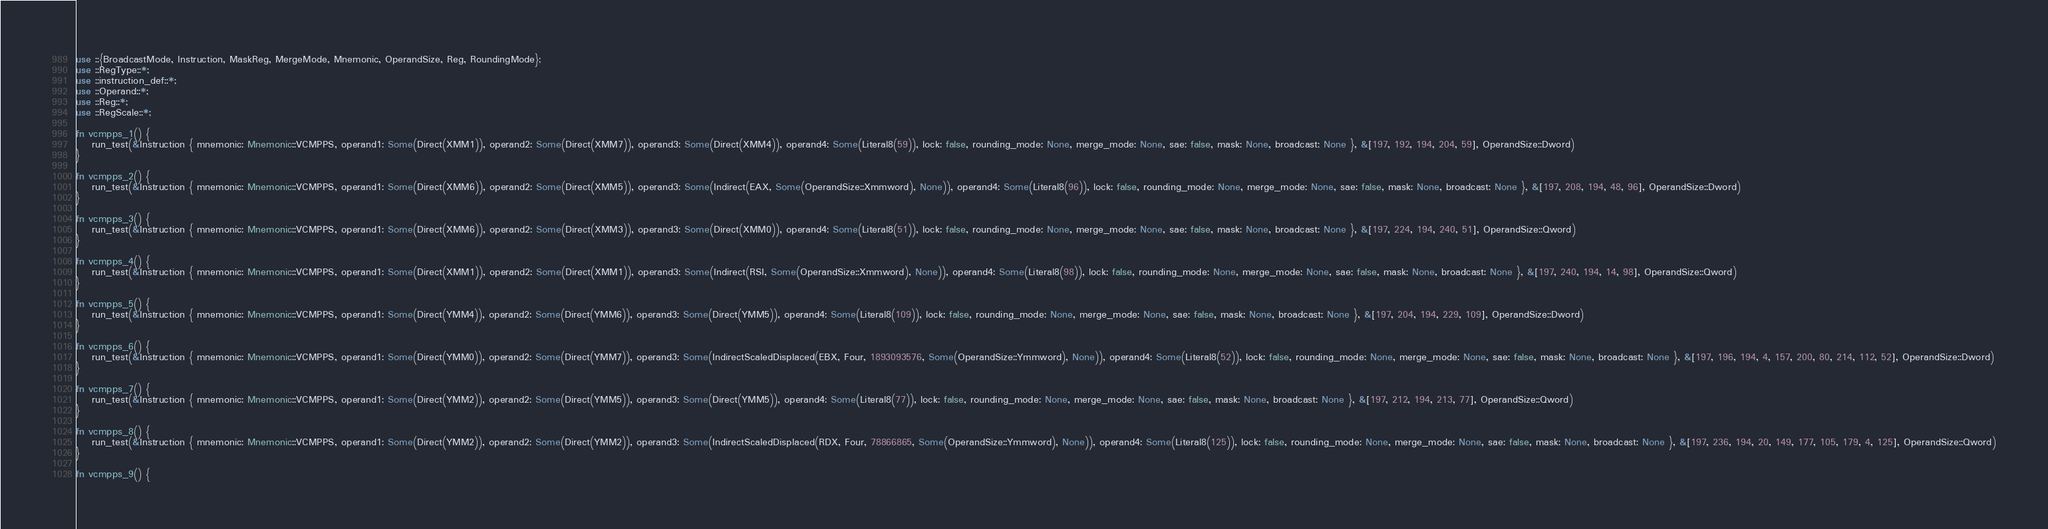Convert code to text. <code><loc_0><loc_0><loc_500><loc_500><_Rust_>use ::{BroadcastMode, Instruction, MaskReg, MergeMode, Mnemonic, OperandSize, Reg, RoundingMode};
use ::RegType::*;
use ::instruction_def::*;
use ::Operand::*;
use ::Reg::*;
use ::RegScale::*;

fn vcmpps_1() {
    run_test(&Instruction { mnemonic: Mnemonic::VCMPPS, operand1: Some(Direct(XMM1)), operand2: Some(Direct(XMM7)), operand3: Some(Direct(XMM4)), operand4: Some(Literal8(59)), lock: false, rounding_mode: None, merge_mode: None, sae: false, mask: None, broadcast: None }, &[197, 192, 194, 204, 59], OperandSize::Dword)
}

fn vcmpps_2() {
    run_test(&Instruction { mnemonic: Mnemonic::VCMPPS, operand1: Some(Direct(XMM6)), operand2: Some(Direct(XMM5)), operand3: Some(Indirect(EAX, Some(OperandSize::Xmmword), None)), operand4: Some(Literal8(96)), lock: false, rounding_mode: None, merge_mode: None, sae: false, mask: None, broadcast: None }, &[197, 208, 194, 48, 96], OperandSize::Dword)
}

fn vcmpps_3() {
    run_test(&Instruction { mnemonic: Mnemonic::VCMPPS, operand1: Some(Direct(XMM6)), operand2: Some(Direct(XMM3)), operand3: Some(Direct(XMM0)), operand4: Some(Literal8(51)), lock: false, rounding_mode: None, merge_mode: None, sae: false, mask: None, broadcast: None }, &[197, 224, 194, 240, 51], OperandSize::Qword)
}

fn vcmpps_4() {
    run_test(&Instruction { mnemonic: Mnemonic::VCMPPS, operand1: Some(Direct(XMM1)), operand2: Some(Direct(XMM1)), operand3: Some(Indirect(RSI, Some(OperandSize::Xmmword), None)), operand4: Some(Literal8(98)), lock: false, rounding_mode: None, merge_mode: None, sae: false, mask: None, broadcast: None }, &[197, 240, 194, 14, 98], OperandSize::Qword)
}

fn vcmpps_5() {
    run_test(&Instruction { mnemonic: Mnemonic::VCMPPS, operand1: Some(Direct(YMM4)), operand2: Some(Direct(YMM6)), operand3: Some(Direct(YMM5)), operand4: Some(Literal8(109)), lock: false, rounding_mode: None, merge_mode: None, sae: false, mask: None, broadcast: None }, &[197, 204, 194, 229, 109], OperandSize::Dword)
}

fn vcmpps_6() {
    run_test(&Instruction { mnemonic: Mnemonic::VCMPPS, operand1: Some(Direct(YMM0)), operand2: Some(Direct(YMM7)), operand3: Some(IndirectScaledDisplaced(EBX, Four, 1893093576, Some(OperandSize::Ymmword), None)), operand4: Some(Literal8(52)), lock: false, rounding_mode: None, merge_mode: None, sae: false, mask: None, broadcast: None }, &[197, 196, 194, 4, 157, 200, 80, 214, 112, 52], OperandSize::Dword)
}

fn vcmpps_7() {
    run_test(&Instruction { mnemonic: Mnemonic::VCMPPS, operand1: Some(Direct(YMM2)), operand2: Some(Direct(YMM5)), operand3: Some(Direct(YMM5)), operand4: Some(Literal8(77)), lock: false, rounding_mode: None, merge_mode: None, sae: false, mask: None, broadcast: None }, &[197, 212, 194, 213, 77], OperandSize::Qword)
}

fn vcmpps_8() {
    run_test(&Instruction { mnemonic: Mnemonic::VCMPPS, operand1: Some(Direct(YMM2)), operand2: Some(Direct(YMM2)), operand3: Some(IndirectScaledDisplaced(RDX, Four, 78866865, Some(OperandSize::Ymmword), None)), operand4: Some(Literal8(125)), lock: false, rounding_mode: None, merge_mode: None, sae: false, mask: None, broadcast: None }, &[197, 236, 194, 20, 149, 177, 105, 179, 4, 125], OperandSize::Qword)
}

fn vcmpps_9() {</code> 